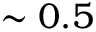<formula> <loc_0><loc_0><loc_500><loc_500>\sim 0 . 5</formula> 